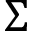<formula> <loc_0><loc_0><loc_500><loc_500>\Sigma</formula> 